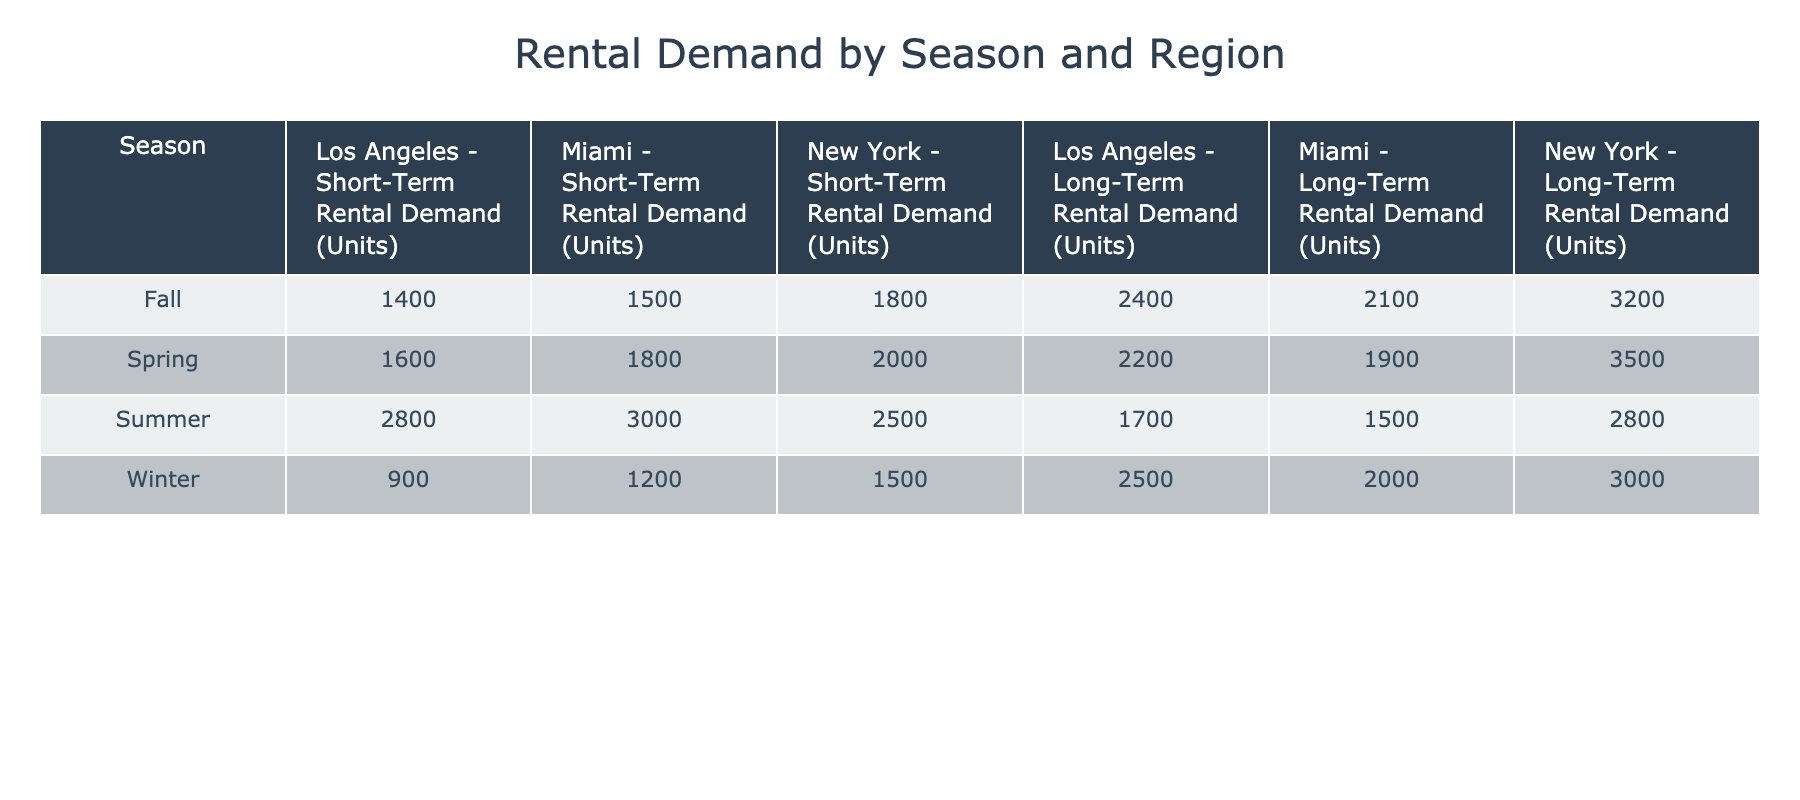What is the short-term rental demand in Miami during the summer? According to the table, the short-term rental demand in Miami for the summer season is explicitly listed as 3000 units.
Answer: 3000 Which region has the highest long-term rental demand during winter? By comparing the long-term rental demand in New York (3000), Miami (2000), and Los Angeles (2500) during winter, New York has the highest demand at 3000 units.
Answer: New York What is the total short-term rental demand across all regions in the spring? The short-term rental demand in the spring is as follows: New York (2000), Miami (1800), and Los Angeles (1600). Adding these values together gives 2000 + 1800 + 1600 = 5400 units.
Answer: 5400 Is the short-term rental demand higher than the long-term rental demand in Los Angeles during the fall? In the fall, Los Angeles has a short-term rental demand of 1400 and a long-term rental demand of 2400. Since 1400 is less than 2400, the answer is no.
Answer: No What is the difference in long-term rental demand between New York and Miami in the summer? The long-term rental demand in New York during summer is 2800 units, while in Miami, it is 1500 units. The difference is calculated as 2800 - 1500 = 1300 units.
Answer: 1300 Which season has the lowest short-term rental demand in Los Angeles? By checking the short-term rental demand for Los Angeles across all seasons, we find winter (900), spring (1600), summer (2800), and fall (1400). The lowest demand is during winter with 900 units.
Answer: Winter What is the average long-term rental demand for Miami across all seasons? The long-term rental demands for Miami across the four seasons are: winter (2000), spring (1900), summer (1500), and fall (2100). Adding these produces 2000 + 1900 + 1500 + 2100 = 7500, and dividing by 4 gives an average of 7500 / 4 = 1875 units.
Answer: 1875 Does the short-term rental demand in spring exceed 2000 units for any region? In spring, the short-term rental demands are 2000 (New York), 1800 (Miami), and 1600 (Los Angeles). The only region where the demand meets or exceeds 2000 units is New York, making the statement true.
Answer: Yes 